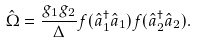Convert formula to latex. <formula><loc_0><loc_0><loc_500><loc_500>\hat { \Omega } = \frac { g _ { 1 } g _ { 2 } } { \Delta } f ( \hat { a } _ { 1 } ^ { \dag } \hat { a } _ { 1 } ) f ( \hat { a } _ { 2 } ^ { \dag } \hat { a } _ { 2 } ) .</formula> 